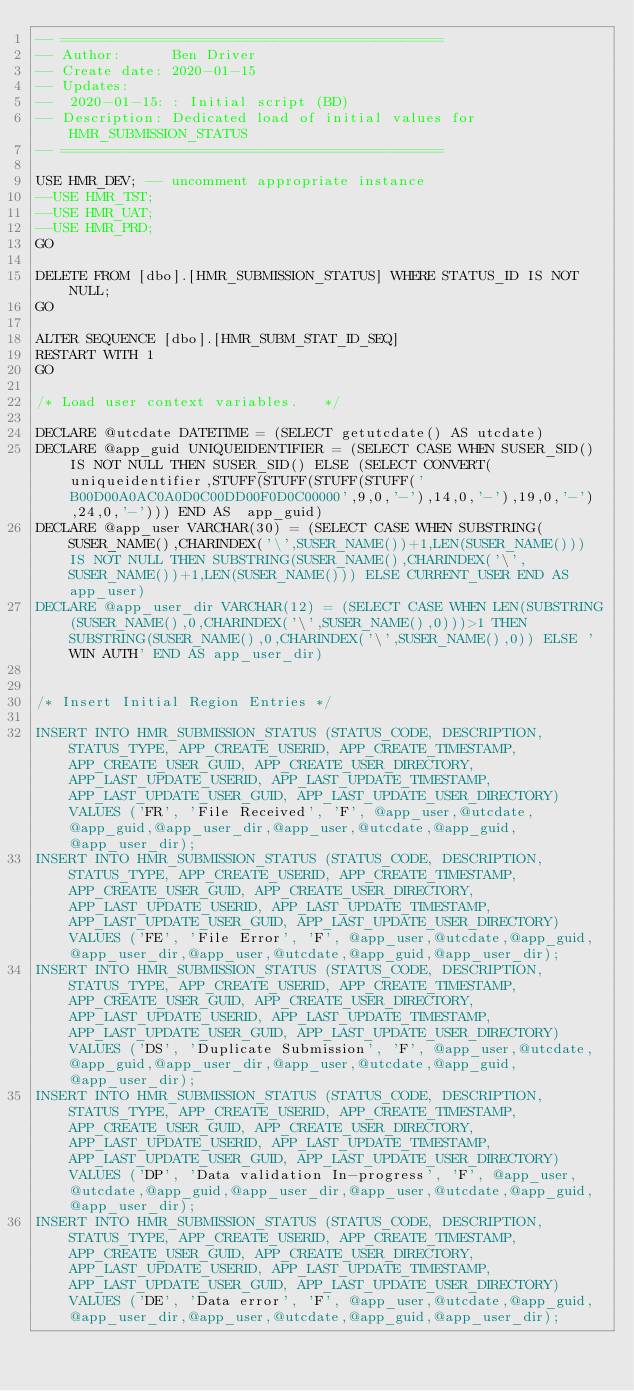Convert code to text. <code><loc_0><loc_0><loc_500><loc_500><_SQL_>-- =============================================
-- Author:		Ben Driver
-- Create date: 2020-01-15
-- Updates: 
--	2020-01-15: : Initial script (BD)
-- Description:	Dedicated load of initial values for HMR_SUBMISSION_STATUS
-- =============================================

USE HMR_DEV; -- uncomment appropriate instance
--USE HMR_TST;
--USE HMR_UAT;
--USE HMR_PRD;
GO

DELETE FROM [dbo].[HMR_SUBMISSION_STATUS] WHERE STATUS_ID IS NOT NULL;
GO

ALTER SEQUENCE [dbo].[HMR_SUBM_STAT_ID_SEQ]
RESTART WITH 1
GO

/* Load user context variables.   */

DECLARE @utcdate DATETIME = (SELECT getutcdate() AS utcdate)
DECLARE @app_guid UNIQUEIDENTIFIER = (SELECT CASE WHEN SUSER_SID() IS NOT NULL THEN SUSER_SID() ELSE (SELECT CONVERT(uniqueidentifier,STUFF(STUFF(STUFF(STUFF('B00D00A0AC0A0D0C00DD00F0D0C00000',9,0,'-'),14,0,'-'),19,0,'-'),24,0,'-'))) END AS  app_guid)
DECLARE @app_user VARCHAR(30) = (SELECT CASE WHEN SUBSTRING(SUSER_NAME(),CHARINDEX('\',SUSER_NAME())+1,LEN(SUSER_NAME())) IS NOT NULL THEN SUBSTRING(SUSER_NAME(),CHARINDEX('\',SUSER_NAME())+1,LEN(SUSER_NAME())) ELSE CURRENT_USER END AS app_user)
DECLARE @app_user_dir VARCHAR(12) = (SELECT CASE WHEN LEN(SUBSTRING(SUSER_NAME(),0,CHARINDEX('\',SUSER_NAME(),0)))>1 THEN SUBSTRING(SUSER_NAME(),0,CHARINDEX('\',SUSER_NAME(),0)) ELSE 'WIN AUTH' END AS app_user_dir)


/* Insert Initial Region Entries */

INSERT INTO HMR_SUBMISSION_STATUS (STATUS_CODE, DESCRIPTION, STATUS_TYPE, APP_CREATE_USERID, APP_CREATE_TIMESTAMP, APP_CREATE_USER_GUID, APP_CREATE_USER_DIRECTORY, APP_LAST_UPDATE_USERID, APP_LAST_UPDATE_TIMESTAMP, APP_LAST_UPDATE_USER_GUID, APP_LAST_UPDATE_USER_DIRECTORY) VALUES ('FR', 'File Received', 'F', @app_user,@utcdate,@app_guid,@app_user_dir,@app_user,@utcdate,@app_guid,@app_user_dir);
INSERT INTO HMR_SUBMISSION_STATUS (STATUS_CODE, DESCRIPTION, STATUS_TYPE, APP_CREATE_USERID, APP_CREATE_TIMESTAMP, APP_CREATE_USER_GUID, APP_CREATE_USER_DIRECTORY, APP_LAST_UPDATE_USERID, APP_LAST_UPDATE_TIMESTAMP, APP_LAST_UPDATE_USER_GUID, APP_LAST_UPDATE_USER_DIRECTORY) VALUES ('FE', 'File Error', 'F', @app_user,@utcdate,@app_guid,@app_user_dir,@app_user,@utcdate,@app_guid,@app_user_dir);
INSERT INTO HMR_SUBMISSION_STATUS (STATUS_CODE, DESCRIPTION, STATUS_TYPE, APP_CREATE_USERID, APP_CREATE_TIMESTAMP, APP_CREATE_USER_GUID, APP_CREATE_USER_DIRECTORY, APP_LAST_UPDATE_USERID, APP_LAST_UPDATE_TIMESTAMP, APP_LAST_UPDATE_USER_GUID, APP_LAST_UPDATE_USER_DIRECTORY) VALUES ('DS', 'Duplicate Submission', 'F', @app_user,@utcdate,@app_guid,@app_user_dir,@app_user,@utcdate,@app_guid,@app_user_dir);
INSERT INTO HMR_SUBMISSION_STATUS (STATUS_CODE, DESCRIPTION, STATUS_TYPE, APP_CREATE_USERID, APP_CREATE_TIMESTAMP, APP_CREATE_USER_GUID, APP_CREATE_USER_DIRECTORY, APP_LAST_UPDATE_USERID, APP_LAST_UPDATE_TIMESTAMP, APP_LAST_UPDATE_USER_GUID, APP_LAST_UPDATE_USER_DIRECTORY) VALUES ('DP', 'Data validation In-progress', 'F', @app_user,@utcdate,@app_guid,@app_user_dir,@app_user,@utcdate,@app_guid,@app_user_dir);
INSERT INTO HMR_SUBMISSION_STATUS (STATUS_CODE, DESCRIPTION, STATUS_TYPE, APP_CREATE_USERID, APP_CREATE_TIMESTAMP, APP_CREATE_USER_GUID, APP_CREATE_USER_DIRECTORY, APP_LAST_UPDATE_USERID, APP_LAST_UPDATE_TIMESTAMP, APP_LAST_UPDATE_USER_GUID, APP_LAST_UPDATE_USER_DIRECTORY) VALUES ('DE', 'Data error', 'F', @app_user,@utcdate,@app_guid,@app_user_dir,@app_user,@utcdate,@app_guid,@app_user_dir);</code> 